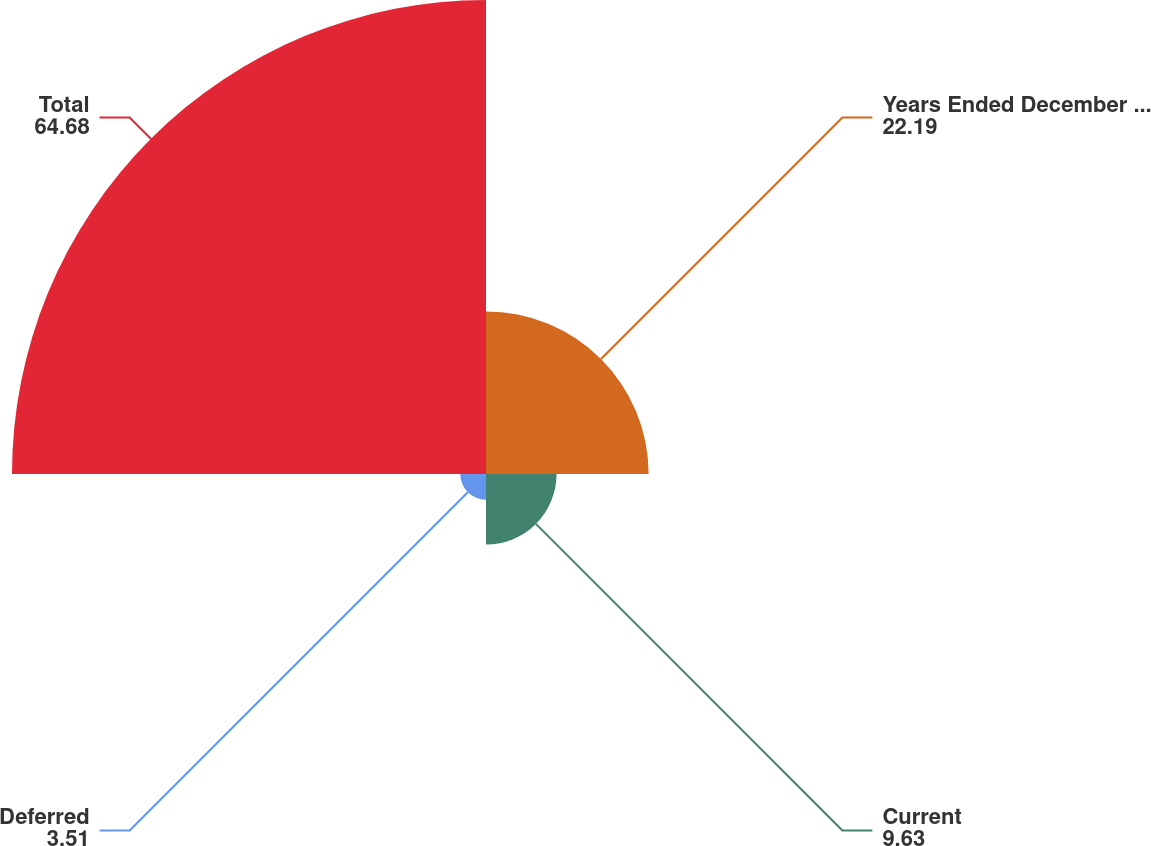Convert chart. <chart><loc_0><loc_0><loc_500><loc_500><pie_chart><fcel>Years Ended December 31 (in<fcel>Current<fcel>Deferred<fcel>Total<nl><fcel>22.19%<fcel>9.63%<fcel>3.51%<fcel>64.68%<nl></chart> 